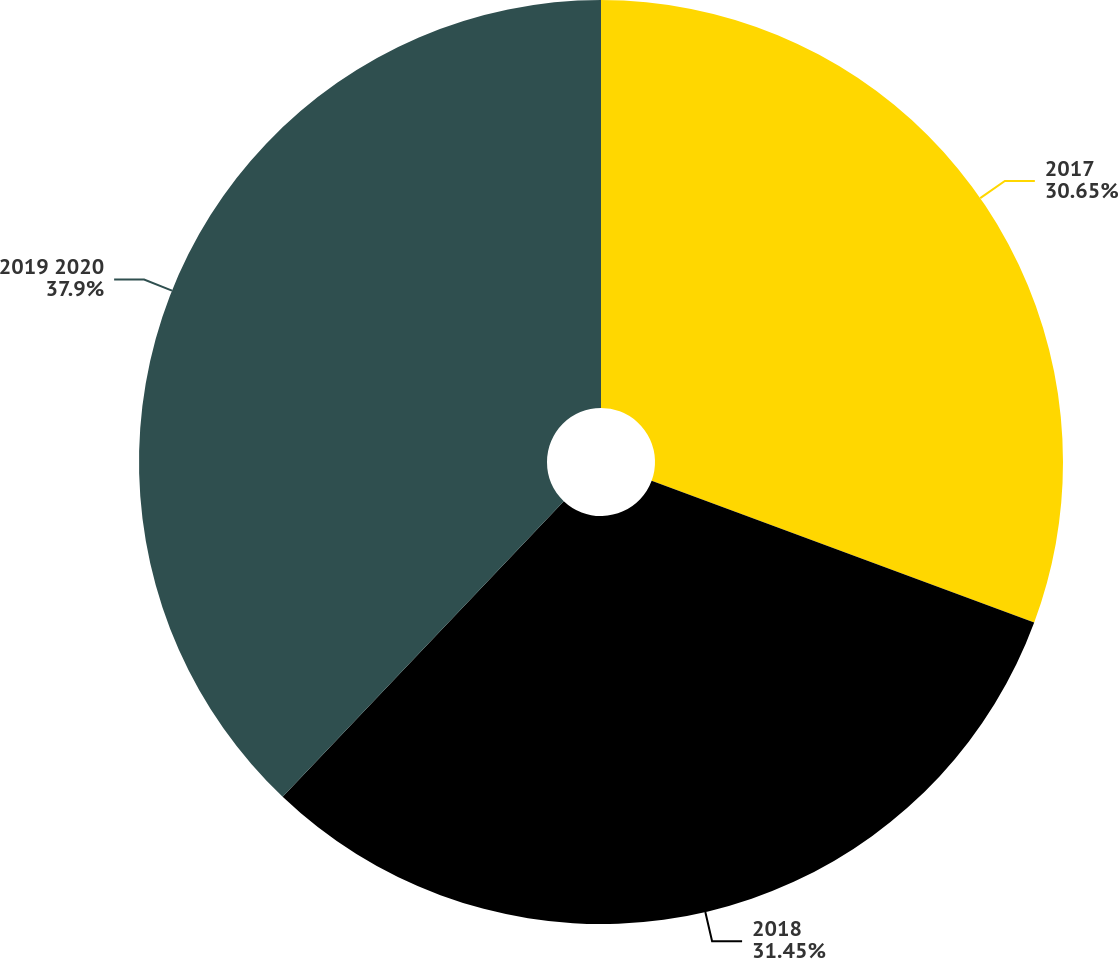<chart> <loc_0><loc_0><loc_500><loc_500><pie_chart><fcel>2017<fcel>2018<fcel>2019 2020<nl><fcel>30.65%<fcel>31.45%<fcel>37.9%<nl></chart> 